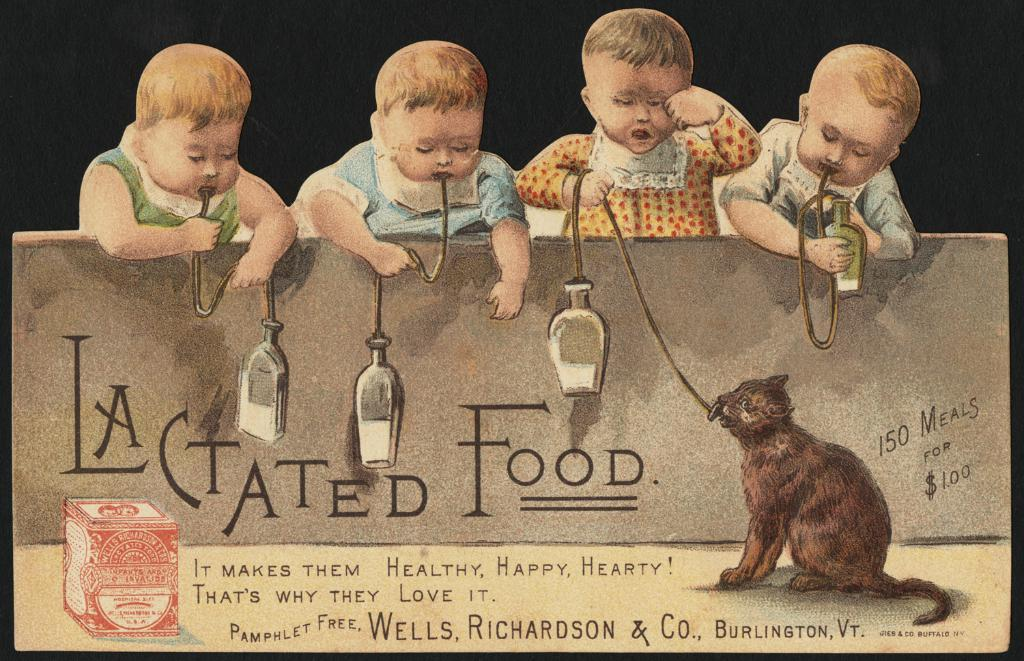What type of image is being described? The image is a poster. What is the cat in the poster doing? The cat is sitting and holding a rope in the poster. How many kids are holding ropes in the poster? There are four kids holding ropes in the poster. What can be seen on the wall in the poster? There are letters and numbers on the wall in the poster. How would you describe the background of the poster? The background of the poster looks dark. What type of scarf is the cat wearing in the poster? There is no scarf present in the poster; the cat is holding a rope. What is the size of the stitch used in the poster? There is no stitching present in the poster, as it is a flat image. 